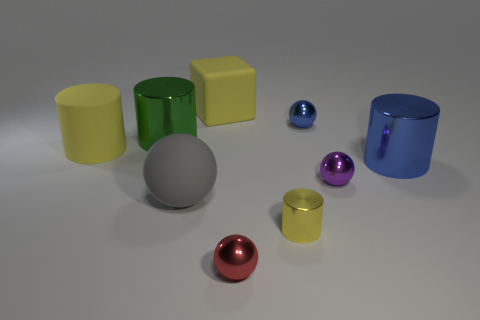What number of purple spheres are there?
Offer a very short reply. 1. Are the green thing and the big gray sphere made of the same material?
Give a very brief answer. No. Are there more rubber cylinders that are behind the big matte sphere than blue metal balls?
Your answer should be compact. No. How many things are either tiny gray shiny cylinders or small metallic objects that are in front of the gray rubber sphere?
Give a very brief answer. 2. Are there more purple metallic spheres on the left side of the yellow cube than red shiny objects right of the red metal thing?
Your response must be concise. No. The big object that is behind the metal cylinder to the left of the tiny metallic sphere to the left of the small blue ball is made of what material?
Keep it short and to the point. Rubber. There is another big object that is the same material as the big green thing; what is its shape?
Offer a very short reply. Cylinder. Are there any small yellow objects that are behind the big rubber thing that is behind the tiny blue ball?
Offer a terse response. No. How big is the blue metal ball?
Make the answer very short. Small. What number of things are either large metallic cylinders or gray cylinders?
Give a very brief answer. 2. 